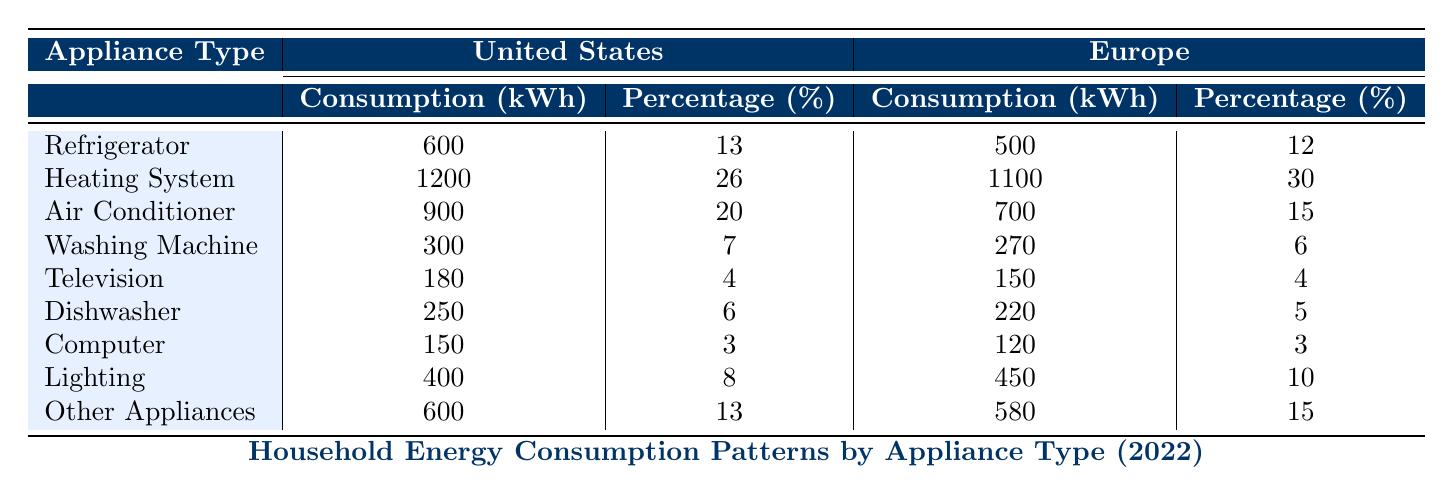What is the average annual consumption of the Heating System in the United States? The table shows that the average annual consumption of the Heating System in the United States is 1200 kWh.
Answer: 1200 kWh What percentage of total consumption does the Washing Machine represent in Europe? From the table, the Washing Machine in Europe has a total consumption percentage of 6%.
Answer: 6% True or false: The Air Conditioner consumes more energy in the United States than in Europe. From the table, the Air Conditioner consumes 900 kWh in the United States and 700 kWh in Europe, which confirms the statement as true.
Answer: True What is the total consumption of Refrigerators and Heating Systems combined in the United States? The average annual consumption for Refrigerators is 600 kWh, and for Heating Systems it is 1200 kWh. Adding these two gives 600 + 1200 = 1800 kWh.
Answer: 1800 kWh Which appliance type has the highest percentage of total consumption in Europe? The highest percentage in Europe is for the Heating System at 30%.
Answer: Heating System What is the difference in average annual consumption of Lighting between the United States and Europe? The average annual consumption for Lighting in the United States is 400 kWh, while in Europe it is 450 kWh. The difference is 450 - 400 = 50 kWh.
Answer: 50 kWh True or false: The total consumption percentage of Other Appliances in Europe is greater than in the United States. The table shows Other Appliances at 15% in Europe and 13% in the United States, confirming the statement is true.
Answer: True What is the average annual consumption of the Computer appliance type across the two regions? The average for the United States is 150 kWh and for Europe is 120 kWh. The average across both is (150 + 120) / 2 = 135 kWh.
Answer: 135 kWh Which appliance consumes 4% of total energy in both regions? The Television appliance type is shown to consume 4% of total energy in both the United States and Europe.
Answer: Television 